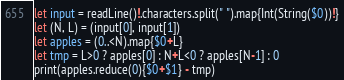<code> <loc_0><loc_0><loc_500><loc_500><_Swift_>let input = readLine()!.characters.split(" ").map{Int(String($0))!}
let (N, L) = (input[0], input[1])
let apples = (0..<N).map{$0+L}
let tmp = L>0 ? apples[0] : N+L<0 ? apples[N-1] : 0
print(apples.reduce(0){$0+$1} - tmp)</code> 